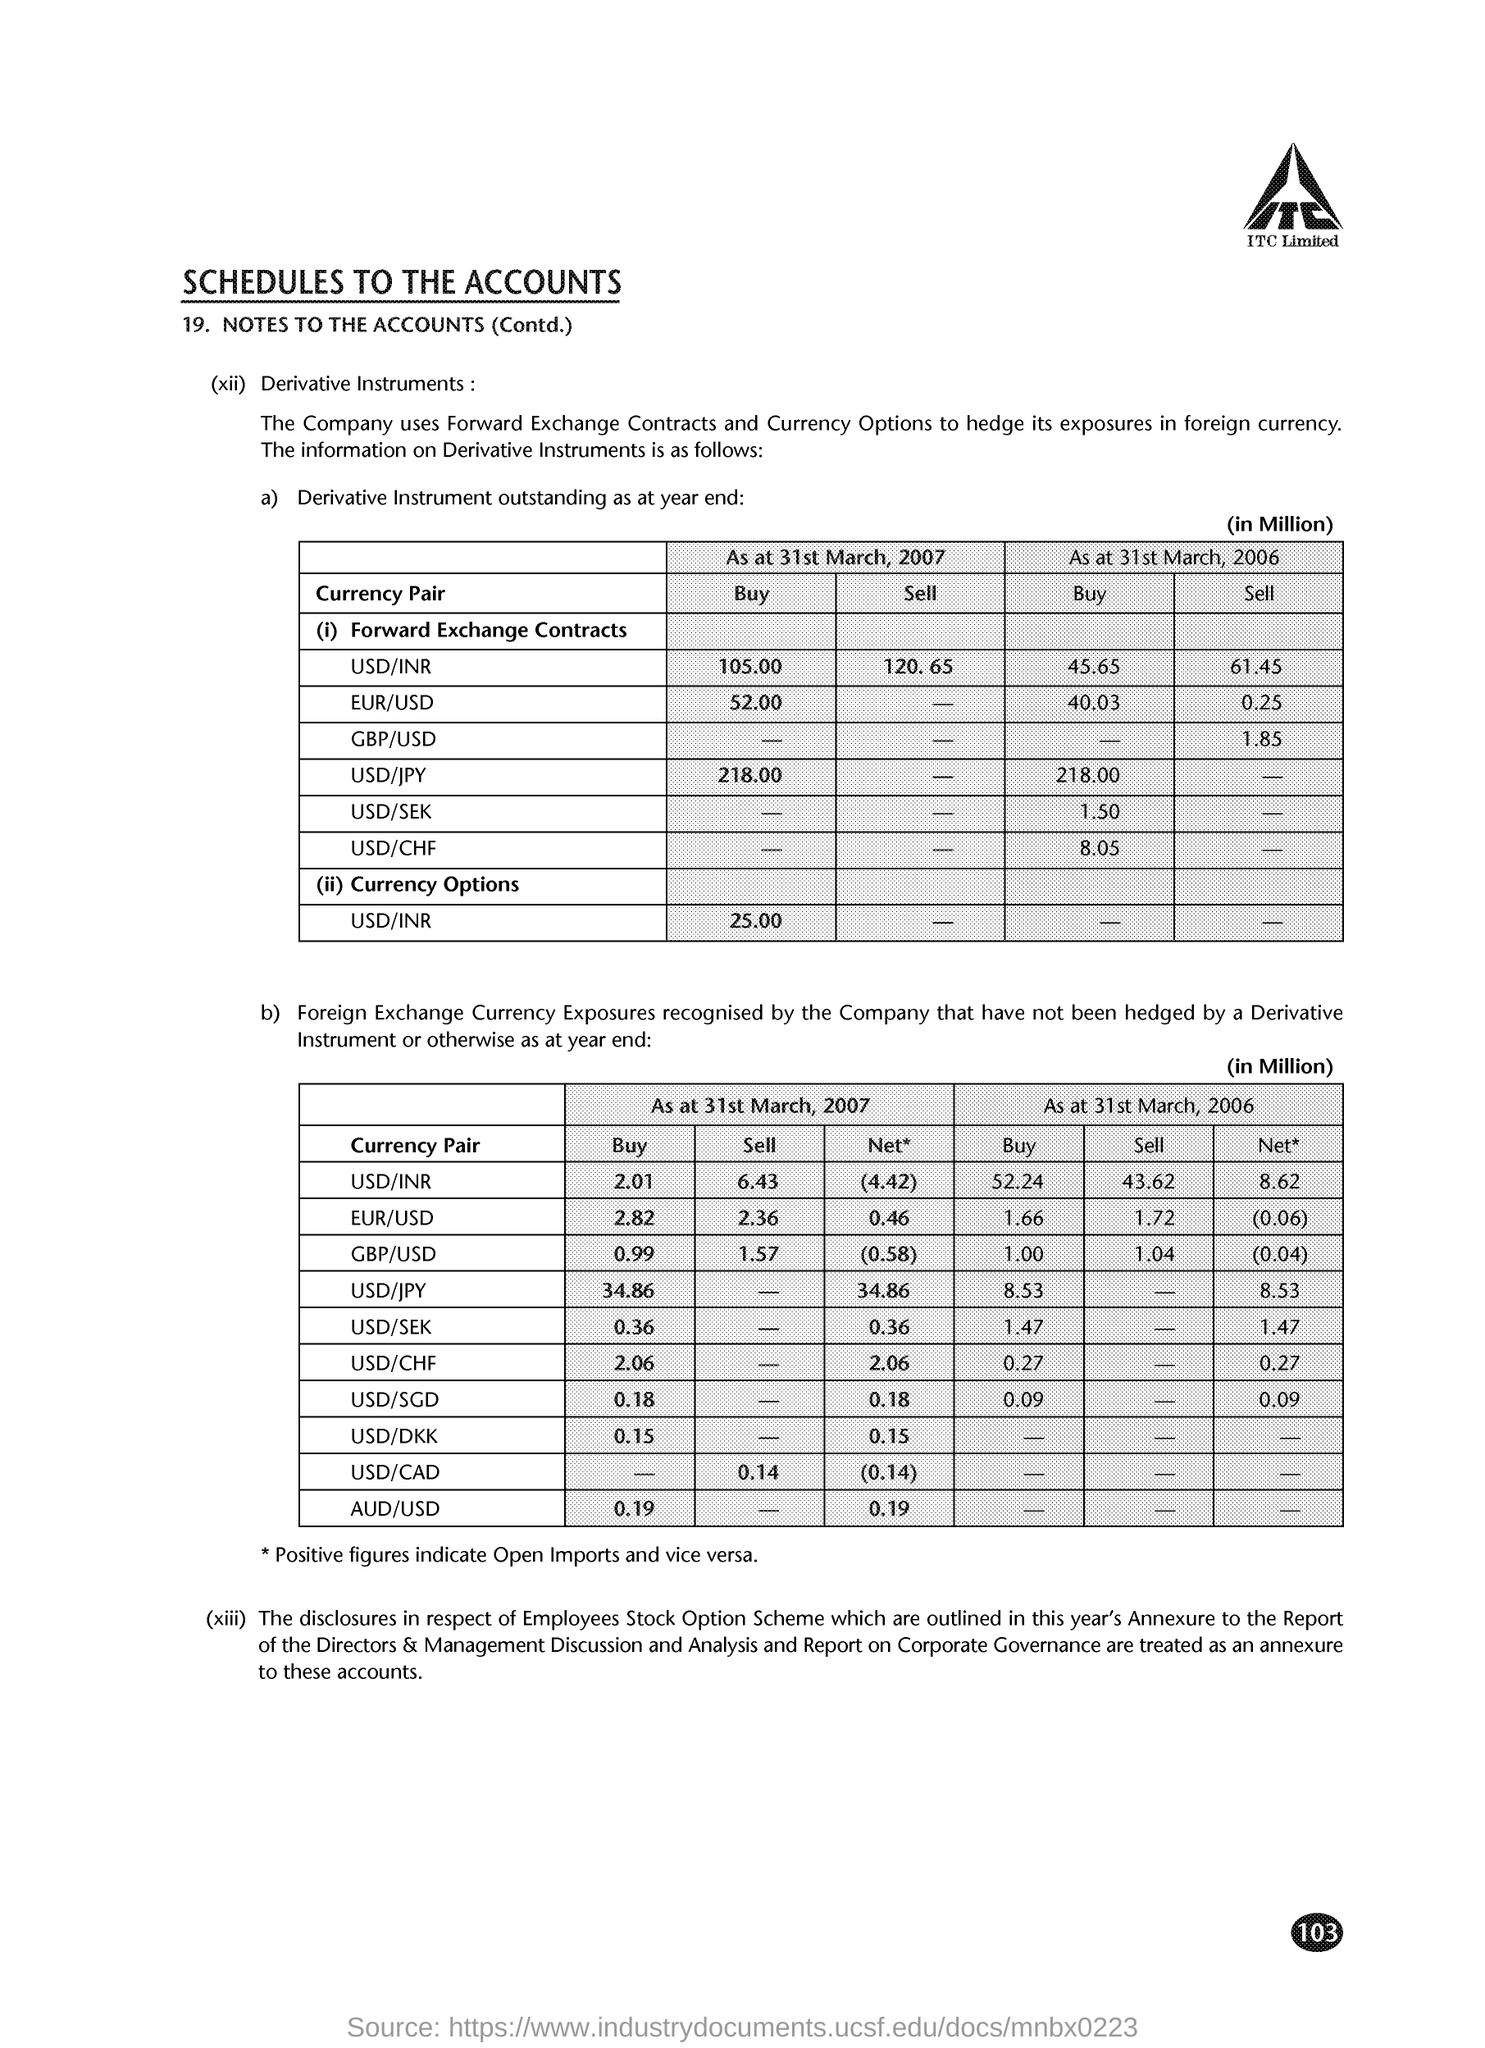Which company's name is at the top of the page?
Give a very brief answer. ITC Limited. What does the Company use to hedge its exposures in foreign currency?
Offer a terse response. Forward Exchange Contracts and Currency Options. What is the page number on this document?
Provide a short and direct response. 103. 